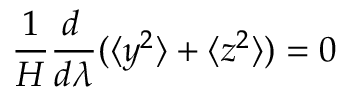Convert formula to latex. <formula><loc_0><loc_0><loc_500><loc_500>{ \frac { 1 } { H } } { \frac { d \, } { d \lambda } } ( \langle y ^ { 2 } \rangle + \langle z ^ { 2 } \rangle ) = 0</formula> 